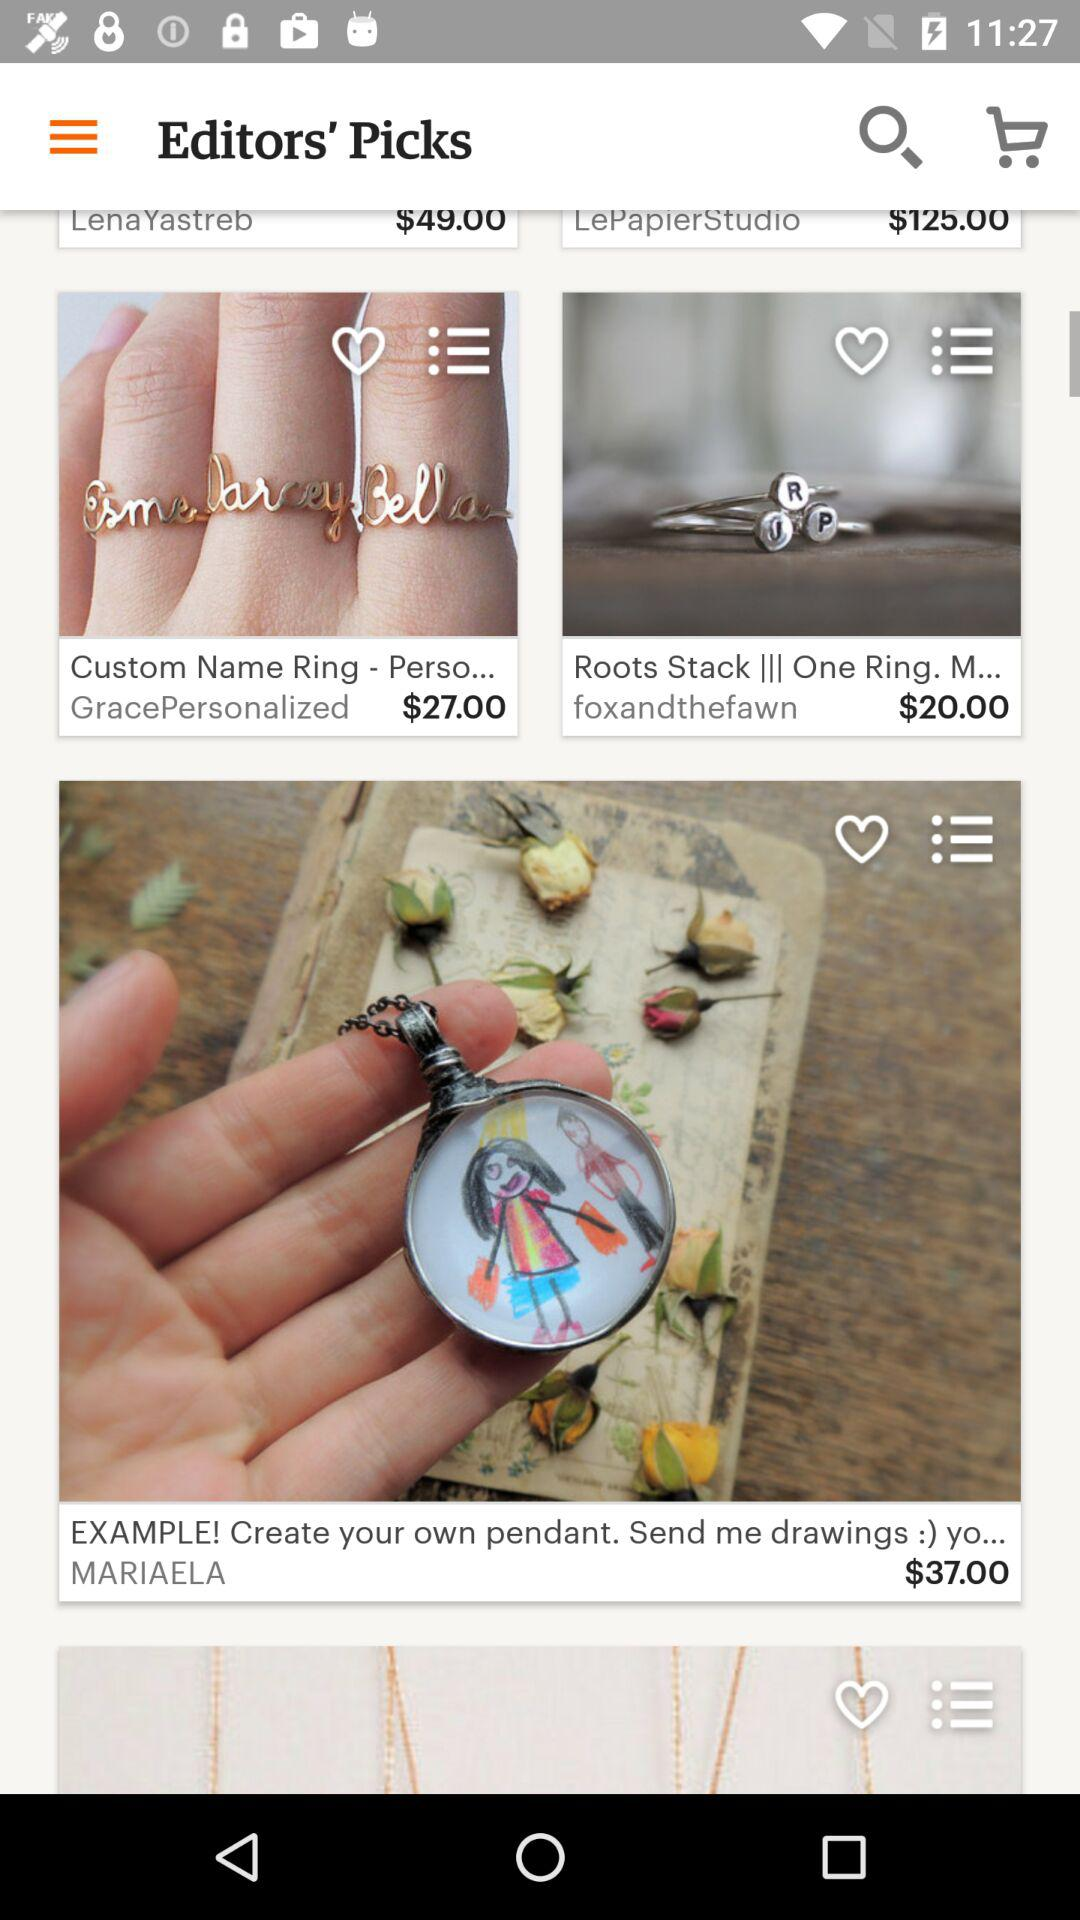What is the application name?
When the provided information is insufficient, respond with <no answer>. <no answer> 